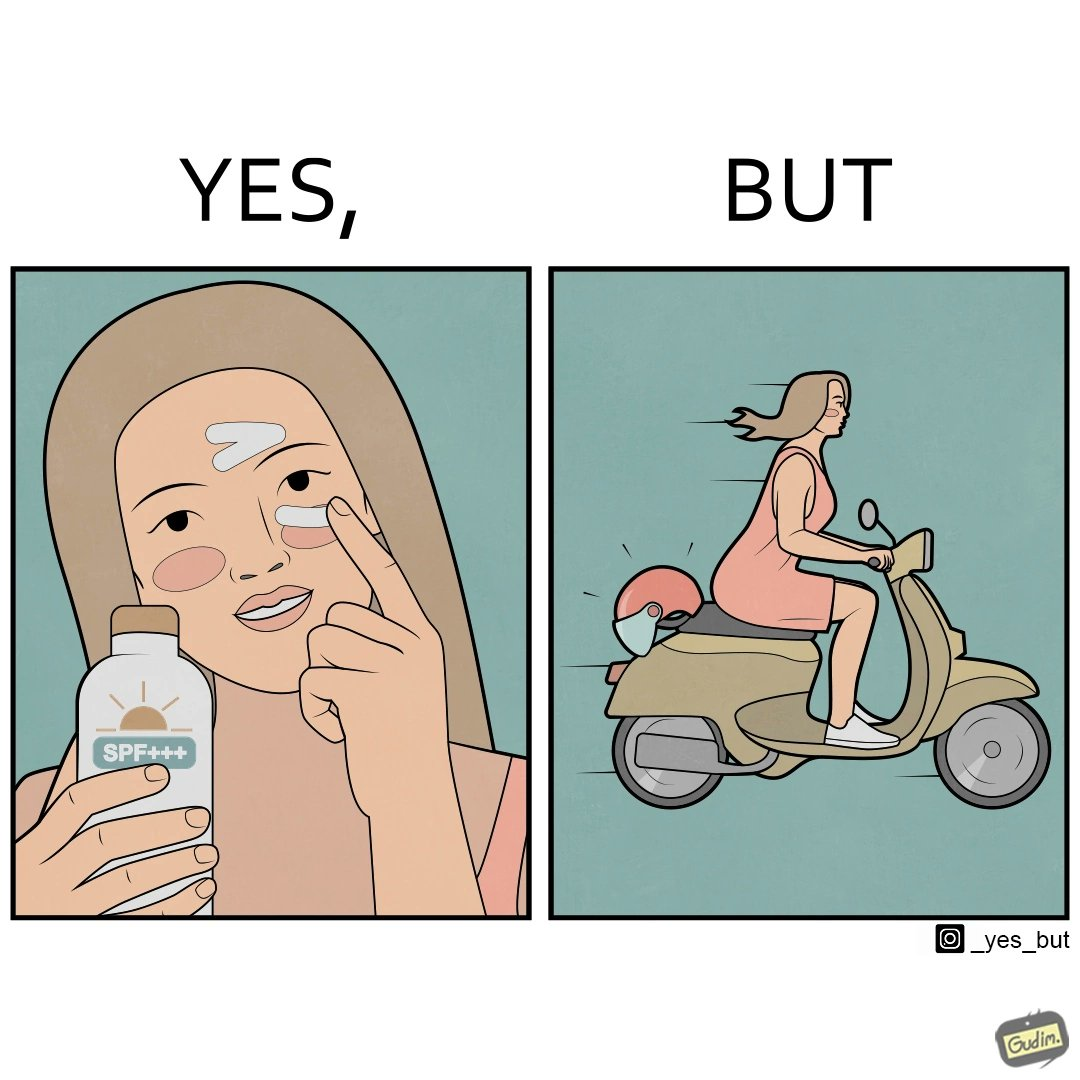What do you see in each half of this image? In the left part of the image: The image shows a woman applying sunscreen with high SPF on her face. In the right part of the image: The image shows a woman riding a scooter with her helmet on the back seat. 